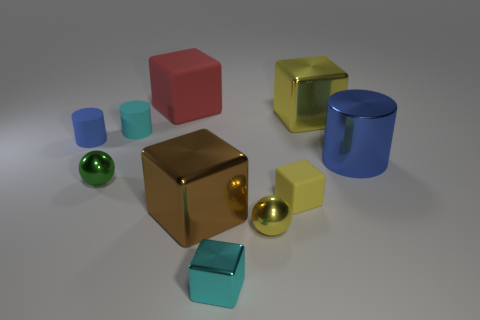Subtract all cyan matte cylinders. How many cylinders are left? 2 Subtract all red balls. How many blue cylinders are left? 2 Subtract 1 cylinders. How many cylinders are left? 2 Subtract all cyan cylinders. How many cylinders are left? 2 Subtract 0 red cylinders. How many objects are left? 10 Subtract all cylinders. How many objects are left? 7 Subtract all yellow cylinders. Subtract all purple balls. How many cylinders are left? 3 Subtract all tiny spheres. Subtract all yellow cubes. How many objects are left? 6 Add 7 tiny shiny things. How many tiny shiny things are left? 10 Add 1 red objects. How many red objects exist? 2 